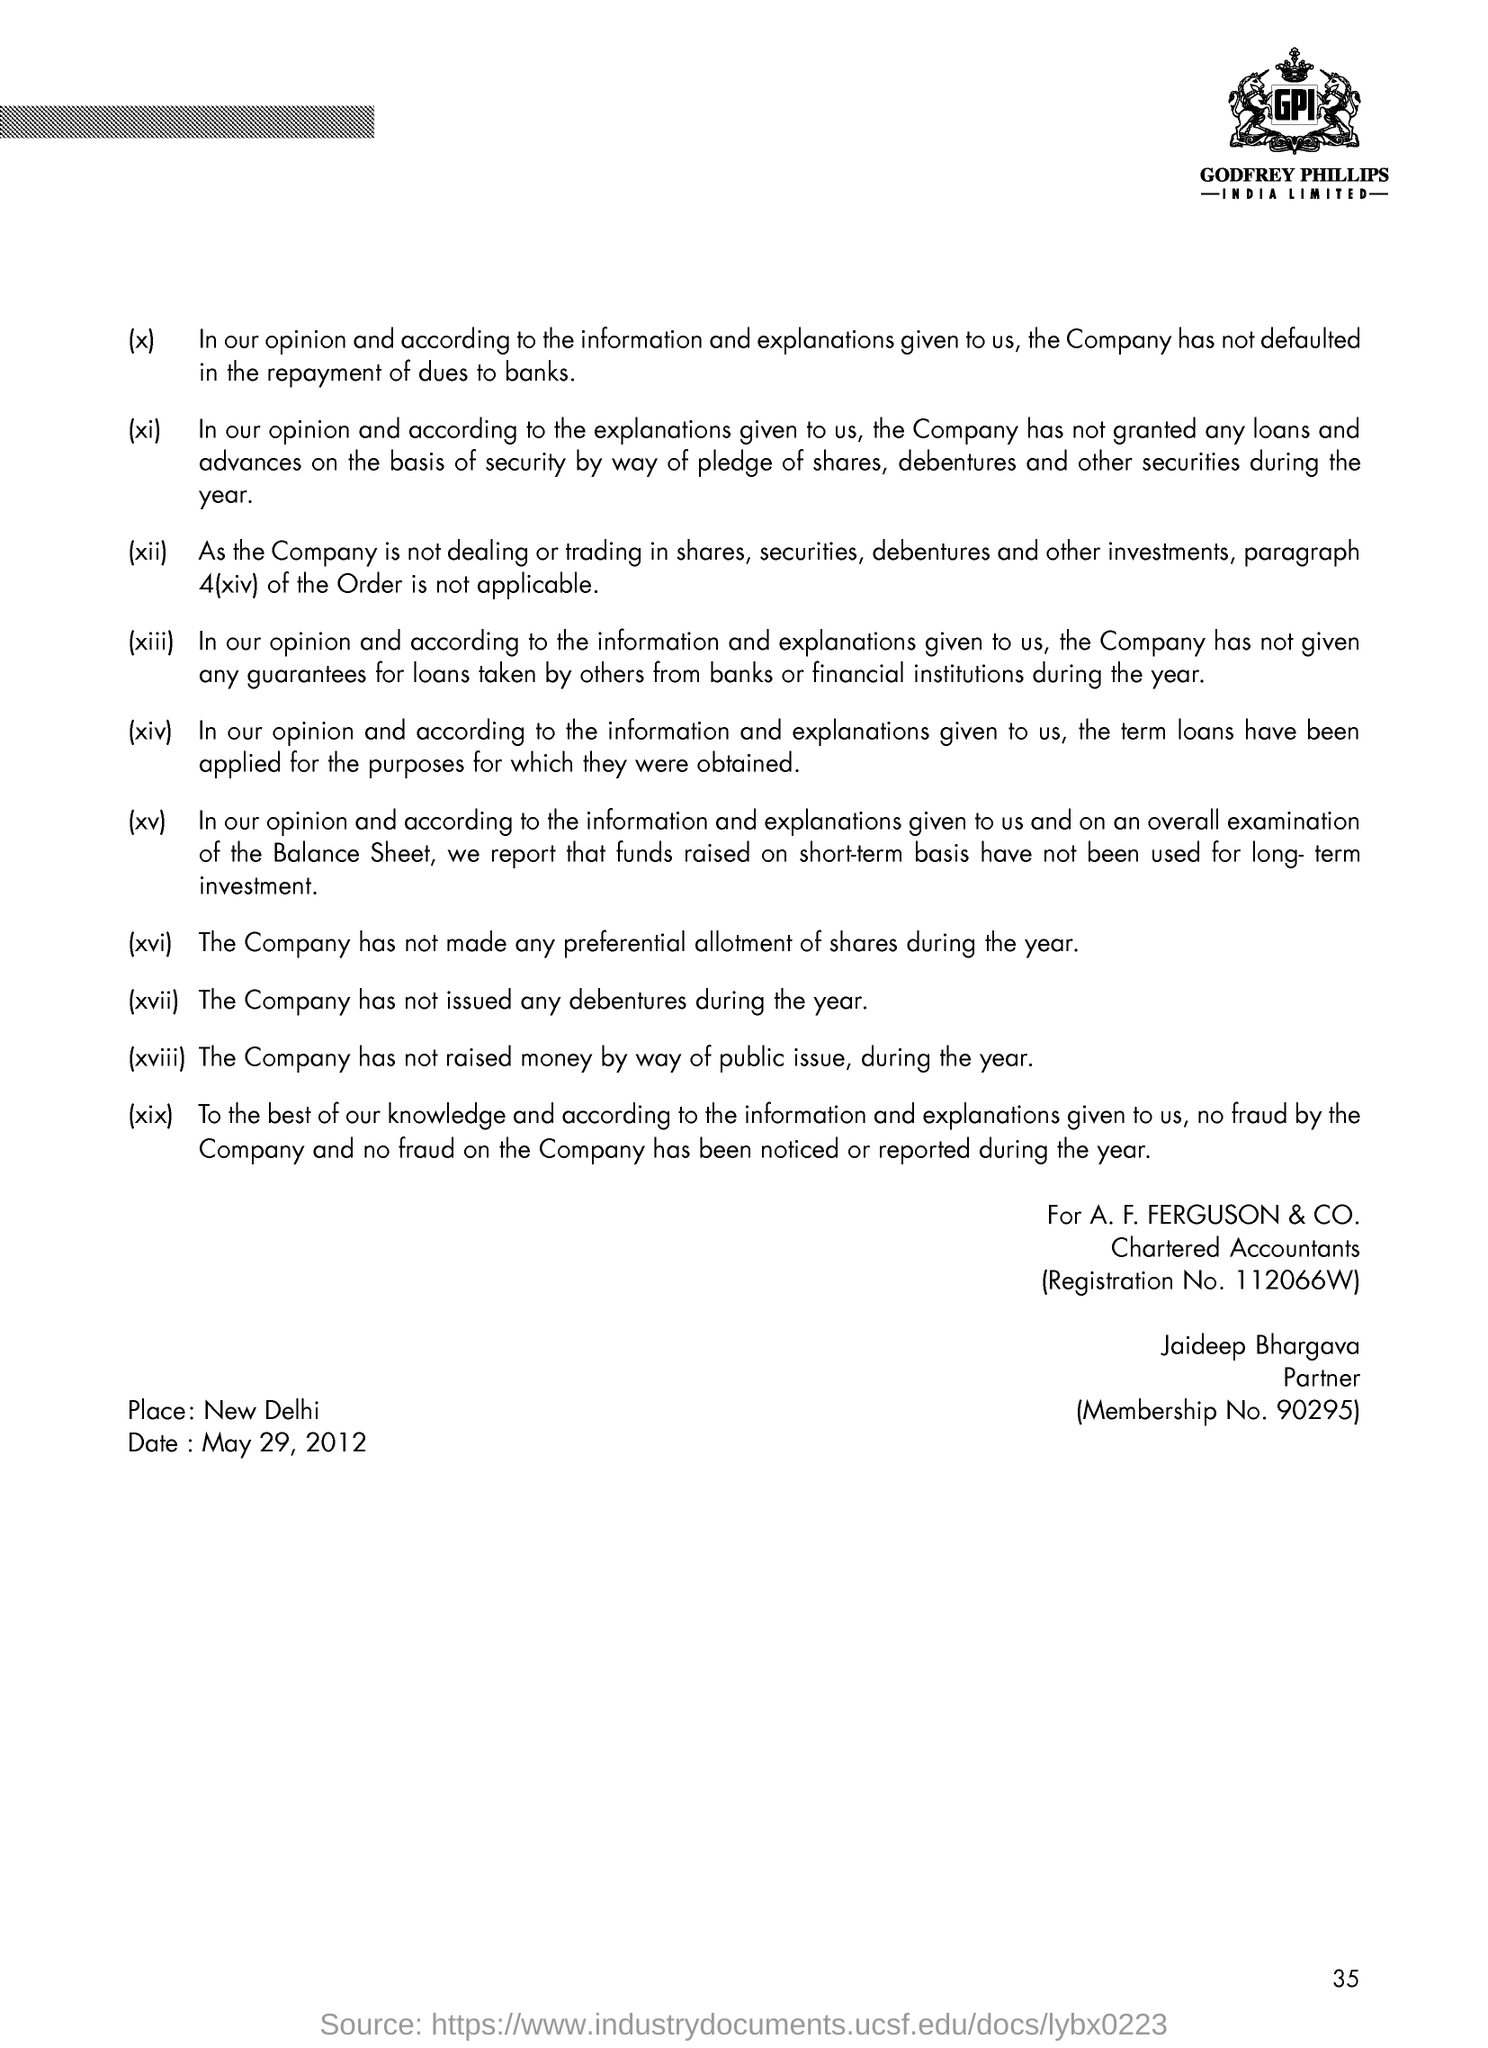Point out several critical features in this image. The document is dated May 29, 2012. The registration number of the chartered accountants is 112066W. Jaideep Bhargava's membership number is 90295... Jaideep Bhargava is designated as a partner. 